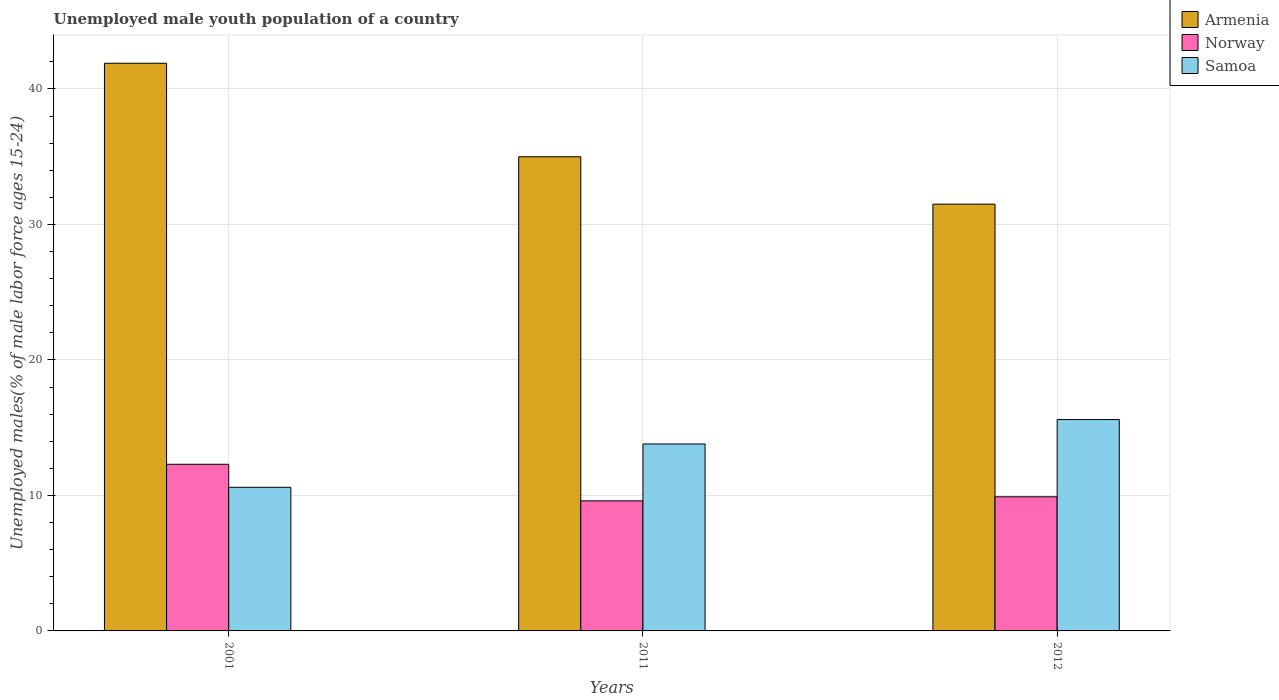How many groups of bars are there?
Provide a short and direct response. 3. Are the number of bars per tick equal to the number of legend labels?
Ensure brevity in your answer.  Yes. How many bars are there on the 1st tick from the left?
Your response must be concise. 3. What is the percentage of unemployed male youth population in Norway in 2011?
Offer a very short reply. 9.6. Across all years, what is the maximum percentage of unemployed male youth population in Armenia?
Offer a terse response. 41.9. Across all years, what is the minimum percentage of unemployed male youth population in Armenia?
Offer a very short reply. 31.5. In which year was the percentage of unemployed male youth population in Norway minimum?
Offer a very short reply. 2011. What is the total percentage of unemployed male youth population in Norway in the graph?
Your response must be concise. 31.8. What is the difference between the percentage of unemployed male youth population in Norway in 2001 and that in 2011?
Offer a terse response. 2.7. What is the difference between the percentage of unemployed male youth population in Armenia in 2011 and the percentage of unemployed male youth population in Norway in 2001?
Ensure brevity in your answer.  22.7. What is the average percentage of unemployed male youth population in Samoa per year?
Ensure brevity in your answer.  13.33. In the year 2012, what is the difference between the percentage of unemployed male youth population in Norway and percentage of unemployed male youth population in Armenia?
Offer a terse response. -21.6. What is the ratio of the percentage of unemployed male youth population in Samoa in 2001 to that in 2012?
Provide a short and direct response. 0.68. Is the percentage of unemployed male youth population in Armenia in 2001 less than that in 2011?
Provide a succinct answer. No. What is the difference between the highest and the second highest percentage of unemployed male youth population in Samoa?
Your answer should be compact. 1.8. What is the difference between the highest and the lowest percentage of unemployed male youth population in Norway?
Your answer should be very brief. 2.7. Is the sum of the percentage of unemployed male youth population in Armenia in 2001 and 2012 greater than the maximum percentage of unemployed male youth population in Samoa across all years?
Make the answer very short. Yes. What does the 1st bar from the left in 2001 represents?
Make the answer very short. Armenia. What does the 3rd bar from the right in 2001 represents?
Your answer should be compact. Armenia. How many years are there in the graph?
Offer a terse response. 3. What is the difference between two consecutive major ticks on the Y-axis?
Offer a very short reply. 10. Does the graph contain any zero values?
Give a very brief answer. No. What is the title of the graph?
Keep it short and to the point. Unemployed male youth population of a country. Does "Thailand" appear as one of the legend labels in the graph?
Your answer should be compact. No. What is the label or title of the Y-axis?
Make the answer very short. Unemployed males(% of male labor force ages 15-24). What is the Unemployed males(% of male labor force ages 15-24) of Armenia in 2001?
Give a very brief answer. 41.9. What is the Unemployed males(% of male labor force ages 15-24) in Norway in 2001?
Ensure brevity in your answer.  12.3. What is the Unemployed males(% of male labor force ages 15-24) in Samoa in 2001?
Offer a terse response. 10.6. What is the Unemployed males(% of male labor force ages 15-24) of Norway in 2011?
Your response must be concise. 9.6. What is the Unemployed males(% of male labor force ages 15-24) in Samoa in 2011?
Your response must be concise. 13.8. What is the Unemployed males(% of male labor force ages 15-24) in Armenia in 2012?
Offer a very short reply. 31.5. What is the Unemployed males(% of male labor force ages 15-24) in Norway in 2012?
Ensure brevity in your answer.  9.9. What is the Unemployed males(% of male labor force ages 15-24) in Samoa in 2012?
Keep it short and to the point. 15.6. Across all years, what is the maximum Unemployed males(% of male labor force ages 15-24) in Armenia?
Offer a terse response. 41.9. Across all years, what is the maximum Unemployed males(% of male labor force ages 15-24) of Norway?
Your response must be concise. 12.3. Across all years, what is the maximum Unemployed males(% of male labor force ages 15-24) of Samoa?
Provide a succinct answer. 15.6. Across all years, what is the minimum Unemployed males(% of male labor force ages 15-24) of Armenia?
Your response must be concise. 31.5. Across all years, what is the minimum Unemployed males(% of male labor force ages 15-24) of Norway?
Keep it short and to the point. 9.6. Across all years, what is the minimum Unemployed males(% of male labor force ages 15-24) in Samoa?
Offer a terse response. 10.6. What is the total Unemployed males(% of male labor force ages 15-24) in Armenia in the graph?
Your answer should be very brief. 108.4. What is the total Unemployed males(% of male labor force ages 15-24) in Norway in the graph?
Your answer should be compact. 31.8. What is the total Unemployed males(% of male labor force ages 15-24) of Samoa in the graph?
Make the answer very short. 40. What is the difference between the Unemployed males(% of male labor force ages 15-24) of Armenia in 2011 and that in 2012?
Make the answer very short. 3.5. What is the difference between the Unemployed males(% of male labor force ages 15-24) in Norway in 2011 and that in 2012?
Ensure brevity in your answer.  -0.3. What is the difference between the Unemployed males(% of male labor force ages 15-24) in Armenia in 2001 and the Unemployed males(% of male labor force ages 15-24) in Norway in 2011?
Ensure brevity in your answer.  32.3. What is the difference between the Unemployed males(% of male labor force ages 15-24) in Armenia in 2001 and the Unemployed males(% of male labor force ages 15-24) in Samoa in 2011?
Your answer should be compact. 28.1. What is the difference between the Unemployed males(% of male labor force ages 15-24) in Armenia in 2001 and the Unemployed males(% of male labor force ages 15-24) in Norway in 2012?
Provide a short and direct response. 32. What is the difference between the Unemployed males(% of male labor force ages 15-24) in Armenia in 2001 and the Unemployed males(% of male labor force ages 15-24) in Samoa in 2012?
Keep it short and to the point. 26.3. What is the difference between the Unemployed males(% of male labor force ages 15-24) of Norway in 2001 and the Unemployed males(% of male labor force ages 15-24) of Samoa in 2012?
Provide a succinct answer. -3.3. What is the difference between the Unemployed males(% of male labor force ages 15-24) of Armenia in 2011 and the Unemployed males(% of male labor force ages 15-24) of Norway in 2012?
Make the answer very short. 25.1. What is the average Unemployed males(% of male labor force ages 15-24) of Armenia per year?
Your answer should be very brief. 36.13. What is the average Unemployed males(% of male labor force ages 15-24) in Norway per year?
Your answer should be compact. 10.6. What is the average Unemployed males(% of male labor force ages 15-24) in Samoa per year?
Your answer should be very brief. 13.33. In the year 2001, what is the difference between the Unemployed males(% of male labor force ages 15-24) of Armenia and Unemployed males(% of male labor force ages 15-24) of Norway?
Offer a very short reply. 29.6. In the year 2001, what is the difference between the Unemployed males(% of male labor force ages 15-24) of Armenia and Unemployed males(% of male labor force ages 15-24) of Samoa?
Give a very brief answer. 31.3. In the year 2001, what is the difference between the Unemployed males(% of male labor force ages 15-24) in Norway and Unemployed males(% of male labor force ages 15-24) in Samoa?
Keep it short and to the point. 1.7. In the year 2011, what is the difference between the Unemployed males(% of male labor force ages 15-24) in Armenia and Unemployed males(% of male labor force ages 15-24) in Norway?
Your response must be concise. 25.4. In the year 2011, what is the difference between the Unemployed males(% of male labor force ages 15-24) of Armenia and Unemployed males(% of male labor force ages 15-24) of Samoa?
Your answer should be compact. 21.2. In the year 2011, what is the difference between the Unemployed males(% of male labor force ages 15-24) in Norway and Unemployed males(% of male labor force ages 15-24) in Samoa?
Ensure brevity in your answer.  -4.2. In the year 2012, what is the difference between the Unemployed males(% of male labor force ages 15-24) in Armenia and Unemployed males(% of male labor force ages 15-24) in Norway?
Provide a short and direct response. 21.6. In the year 2012, what is the difference between the Unemployed males(% of male labor force ages 15-24) in Norway and Unemployed males(% of male labor force ages 15-24) in Samoa?
Offer a very short reply. -5.7. What is the ratio of the Unemployed males(% of male labor force ages 15-24) in Armenia in 2001 to that in 2011?
Provide a succinct answer. 1.2. What is the ratio of the Unemployed males(% of male labor force ages 15-24) of Norway in 2001 to that in 2011?
Your answer should be very brief. 1.28. What is the ratio of the Unemployed males(% of male labor force ages 15-24) of Samoa in 2001 to that in 2011?
Your response must be concise. 0.77. What is the ratio of the Unemployed males(% of male labor force ages 15-24) of Armenia in 2001 to that in 2012?
Your answer should be compact. 1.33. What is the ratio of the Unemployed males(% of male labor force ages 15-24) of Norway in 2001 to that in 2012?
Make the answer very short. 1.24. What is the ratio of the Unemployed males(% of male labor force ages 15-24) in Samoa in 2001 to that in 2012?
Your answer should be very brief. 0.68. What is the ratio of the Unemployed males(% of male labor force ages 15-24) in Norway in 2011 to that in 2012?
Ensure brevity in your answer.  0.97. What is the ratio of the Unemployed males(% of male labor force ages 15-24) in Samoa in 2011 to that in 2012?
Ensure brevity in your answer.  0.88. What is the difference between the highest and the second highest Unemployed males(% of male labor force ages 15-24) in Armenia?
Ensure brevity in your answer.  6.9. What is the difference between the highest and the second highest Unemployed males(% of male labor force ages 15-24) of Norway?
Offer a very short reply. 2.4. What is the difference between the highest and the second highest Unemployed males(% of male labor force ages 15-24) in Samoa?
Give a very brief answer. 1.8. What is the difference between the highest and the lowest Unemployed males(% of male labor force ages 15-24) in Samoa?
Give a very brief answer. 5. 